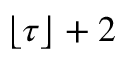<formula> <loc_0><loc_0><loc_500><loc_500>\lfloor \tau \rfloor + 2</formula> 